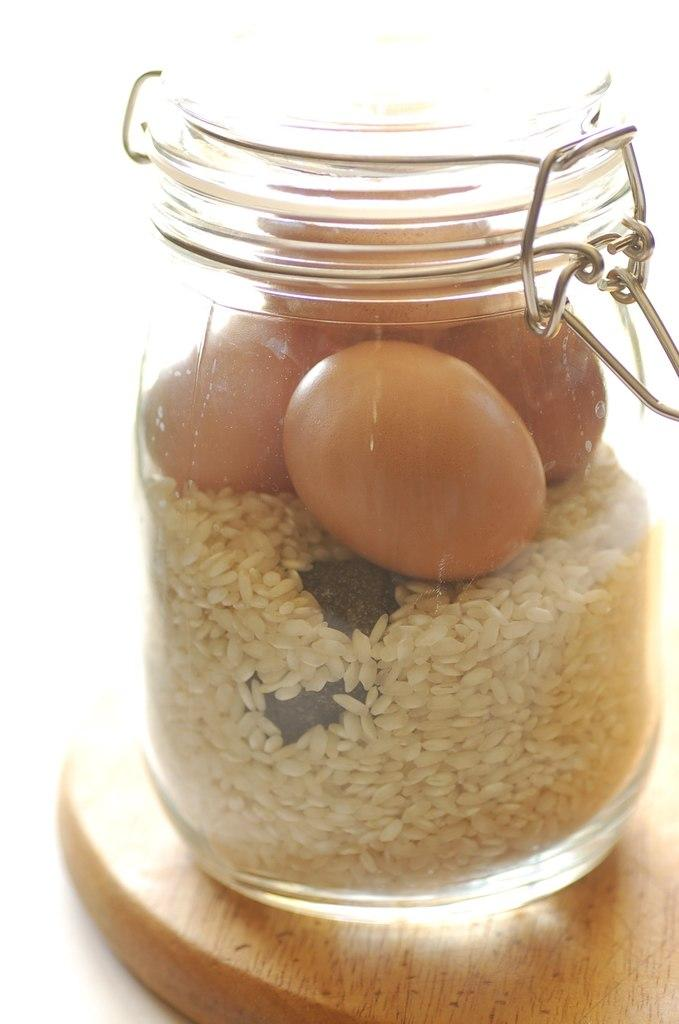What object is visible in the image that contains food grains and eggs? There is a glass jar in the image that contains food grains and eggs. Where is the glass jar placed? The glass jar is placed on a wooden table. What is the color of the background in the image? The background of the image is white in color. Is there a squirrel expressing regret in the image? There is no squirrel or any expression of regret present in the image. 